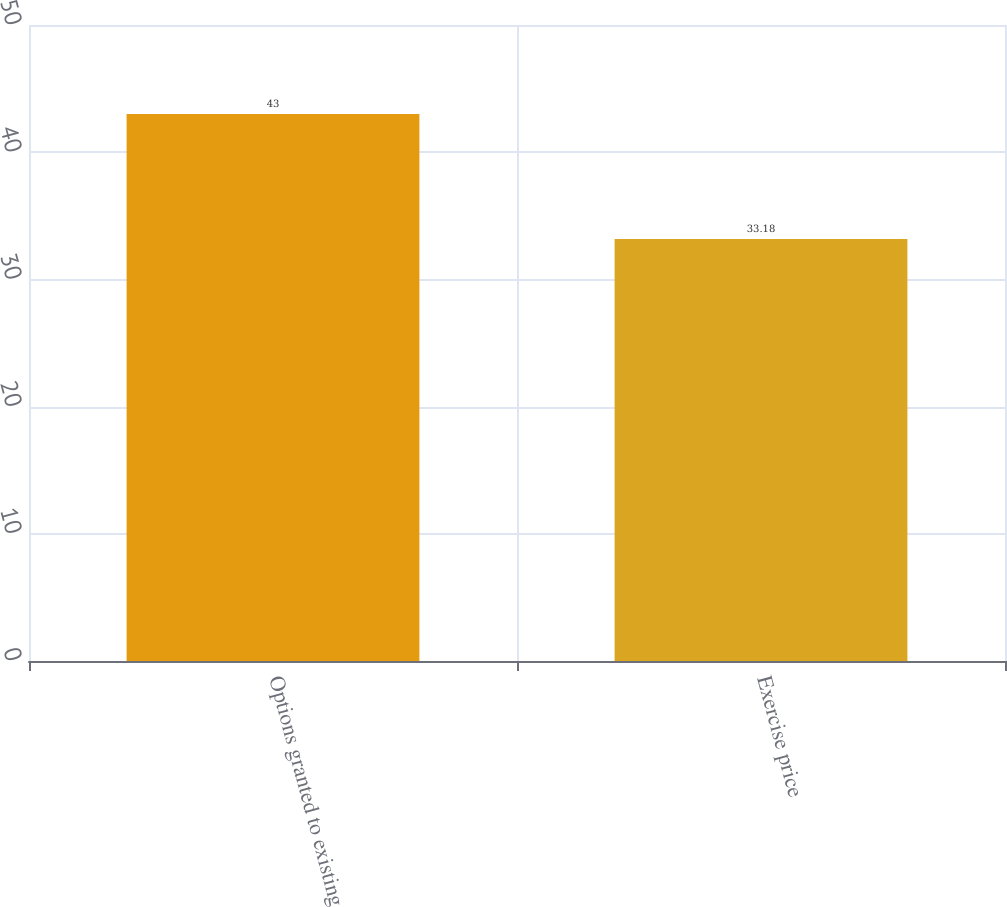Convert chart to OTSL. <chart><loc_0><loc_0><loc_500><loc_500><bar_chart><fcel>Options granted to existing<fcel>Exercise price<nl><fcel>43<fcel>33.18<nl></chart> 